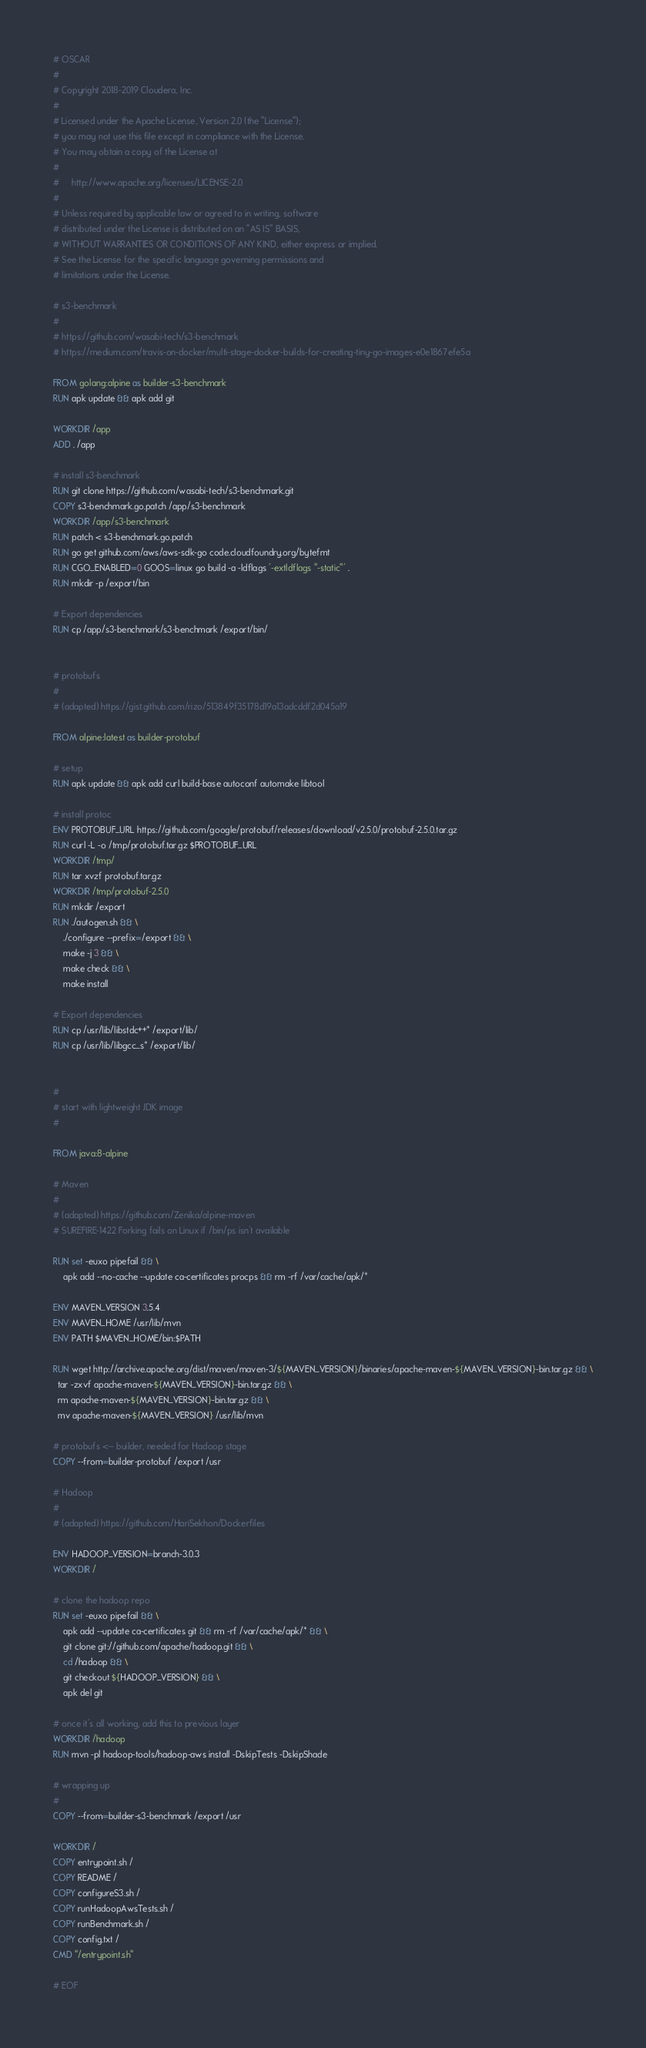<code> <loc_0><loc_0><loc_500><loc_500><_Dockerfile_># OSCAR
#
# Copyright 2018-2019 Cloudera, Inc.
#
# Licensed under the Apache License, Version 2.0 (the "License");
# you may not use this file except in compliance with the License.
# You may obtain a copy of the License at
#
#     http://www.apache.org/licenses/LICENSE-2.0
#
# Unless required by applicable law or agreed to in writing, software
# distributed under the License is distributed on an "AS IS" BASIS,
# WITHOUT WARRANTIES OR CONDITIONS OF ANY KIND, either express or implied.
# See the License for the specific language governing permissions and
# limitations under the License.

# s3-benchmark
#
# https://github.com/wasabi-tech/s3-benchmark
# https://medium.com/travis-on-docker/multi-stage-docker-builds-for-creating-tiny-go-images-e0e1867efe5a

FROM golang:alpine as builder-s3-benchmark
RUN apk update && apk add git

WORKDIR /app
ADD . /app

# install s3-benchmark
RUN git clone https://github.com/wasabi-tech/s3-benchmark.git
COPY s3-benchmark.go.patch /app/s3-benchmark
WORKDIR /app/s3-benchmark
RUN patch < s3-benchmark.go.patch
RUN go get github.com/aws/aws-sdk-go code.cloudfoundry.org/bytefmt
RUN CGO_ENABLED=0 GOOS=linux go build -a -ldflags '-extldflags "-static"' .
RUN mkdir -p /export/bin

# Export dependencies
RUN cp /app/s3-benchmark/s3-benchmark /export/bin/


# protobufs
#
# (adapted) https://gist.github.com/rizo/513849f35178d19a13adcddf2d045a19

FROM alpine:latest as builder-protobuf

# setup
RUN apk update && apk add curl build-base autoconf automake libtool

# install protoc
ENV PROTOBUF_URL https://github.com/google/protobuf/releases/download/v2.5.0/protobuf-2.5.0.tar.gz
RUN curl -L -o /tmp/protobuf.tar.gz $PROTOBUF_URL
WORKDIR /tmp/
RUN tar xvzf protobuf.tar.gz
WORKDIR /tmp/protobuf-2.5.0
RUN mkdir /export
RUN ./autogen.sh && \
    ./configure --prefix=/export && \
    make -j 3 && \
    make check && \
    make install

# Export dependencies
RUN cp /usr/lib/libstdc++* /export/lib/
RUN cp /usr/lib/libgcc_s* /export/lib/


#
# start with lightweight JDK image
#

FROM java:8-alpine

# Maven
#
# (adapted) https://github.com/Zenika/alpine-maven
# SUREFIRE-1422 Forking fails on Linux if /bin/ps isn't available

RUN set -euxo pipefail && \
    apk add --no-cache --update ca-certificates procps && rm -rf /var/cache/apk/* 

ENV MAVEN_VERSION 3.5.4
ENV MAVEN_HOME /usr/lib/mvn
ENV PATH $MAVEN_HOME/bin:$PATH

RUN wget http://archive.apache.org/dist/maven/maven-3/${MAVEN_VERSION}/binaries/apache-maven-${MAVEN_VERSION}-bin.tar.gz && \
  tar -zxvf apache-maven-${MAVEN_VERSION}-bin.tar.gz && \
  rm apache-maven-${MAVEN_VERSION}-bin.tar.gz && \
  mv apache-maven-${MAVEN_VERSION} /usr/lib/mvn

# protobufs <-- builder, needed for Hadoop stage
COPY --from=builder-protobuf /export /usr

# Hadoop
#
# (adapted) https://github.com/HariSekhon/Dockerfiles

ENV HADOOP_VERSION=branch-3.0.3
WORKDIR /

# clone the hadoop repo
RUN set -euxo pipefail && \
    apk add --update ca-certificates git && rm -rf /var/cache/apk/* && \
    git clone git://github.com/apache/hadoop.git && \
    cd /hadoop && \
    git checkout ${HADOOP_VERSION} && \
    apk del git

# once it's all working, add this to previous layer
WORKDIR /hadoop
RUN mvn -pl hadoop-tools/hadoop-aws install -DskipTests -DskipShade

# wrapping up
#
COPY --from=builder-s3-benchmark /export /usr

WORKDIR /
COPY entrypoint.sh /
COPY README /
COPY configureS3.sh /
COPY runHadoopAwsTests.sh /
COPY runBenchmark.sh /
COPY config.txt /
CMD "/entrypoint.sh"

# EOF
</code> 